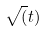<formula> <loc_0><loc_0><loc_500><loc_500>\sqrt { ( } t )</formula> 